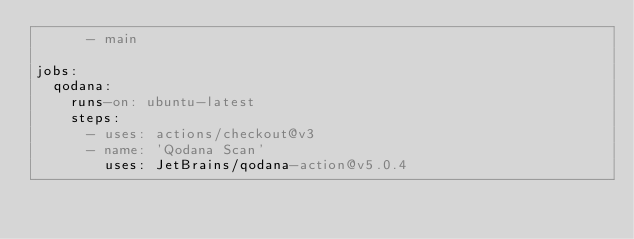Convert code to text. <code><loc_0><loc_0><loc_500><loc_500><_YAML_>      - main

jobs:
  qodana:
    runs-on: ubuntu-latest
    steps:
      - uses: actions/checkout@v3
      - name: 'Qodana Scan'
        uses: JetBrains/qodana-action@v5.0.4
</code> 